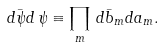Convert formula to latex. <formula><loc_0><loc_0><loc_500><loc_500>d \bar { \psi } d \, \psi \equiv \prod _ { m } \, d \bar { b } _ { m } d a _ { m } .</formula> 